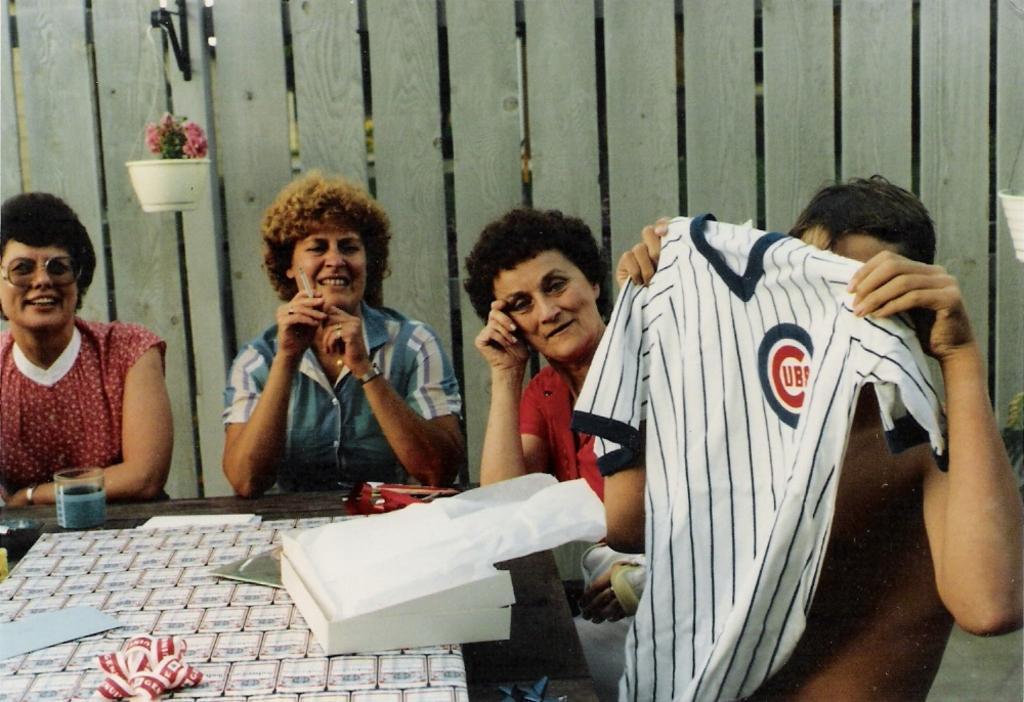Describe this image in one or two sentences. In this image I can see few people are sitting. I can also see smile on few faces and here I can see a table. On this table I can see a white colour box, a glass and few other stuffs. In background I can see plant in white colour pot and here I can see one person is holding white colour cloth. 